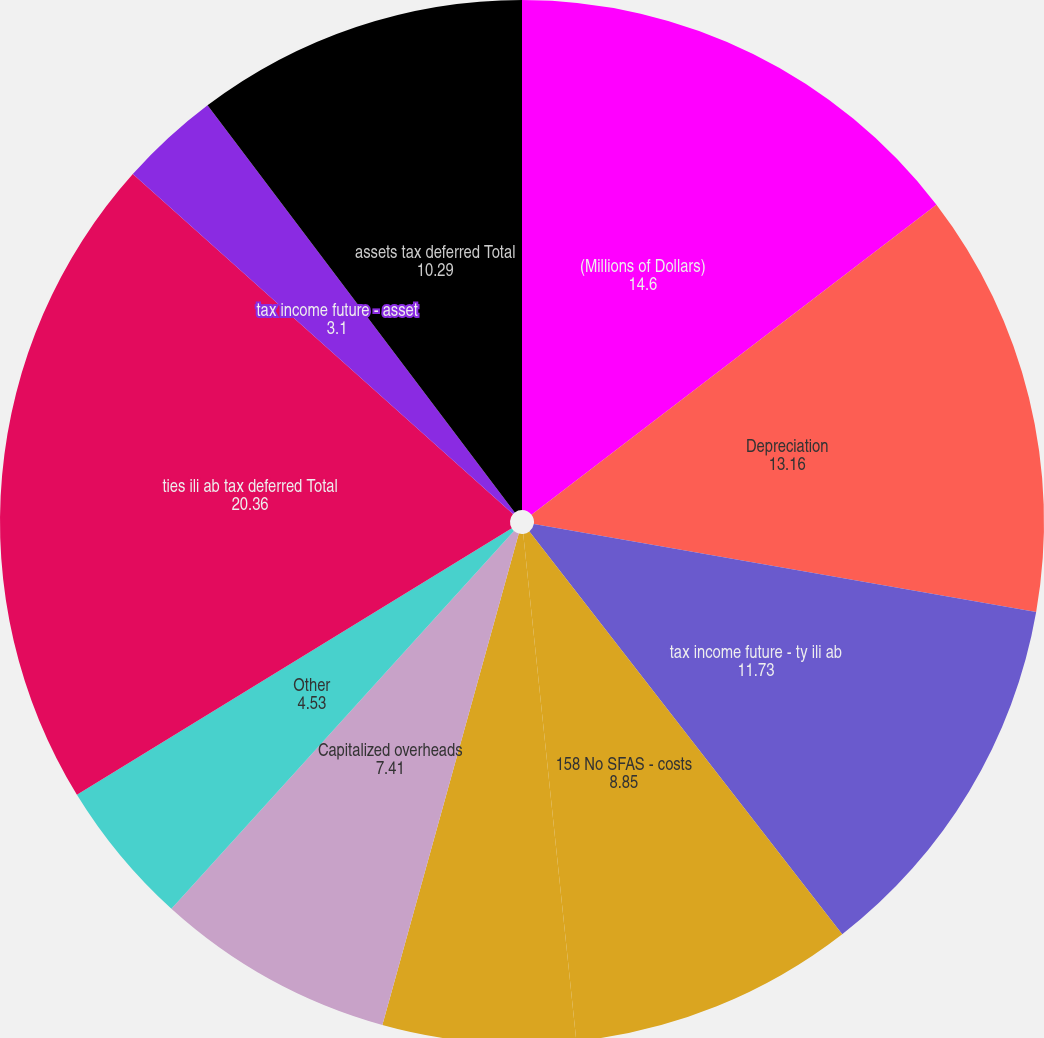Convert chart to OTSL. <chart><loc_0><loc_0><loc_500><loc_500><pie_chart><fcel>(Millions of Dollars)<fcel>Depreciation<fcel>tax income future - ty ili ab<fcel>158 No SFAS - costs<fcel>State income tax<fcel>Capitalized overheads<fcel>Other<fcel>ties ili ab tax deferred Total<fcel>tax income future - asset<fcel>assets tax deferred Total<nl><fcel>14.6%<fcel>13.16%<fcel>11.73%<fcel>8.85%<fcel>5.97%<fcel>7.41%<fcel>4.53%<fcel>20.36%<fcel>3.1%<fcel>10.29%<nl></chart> 